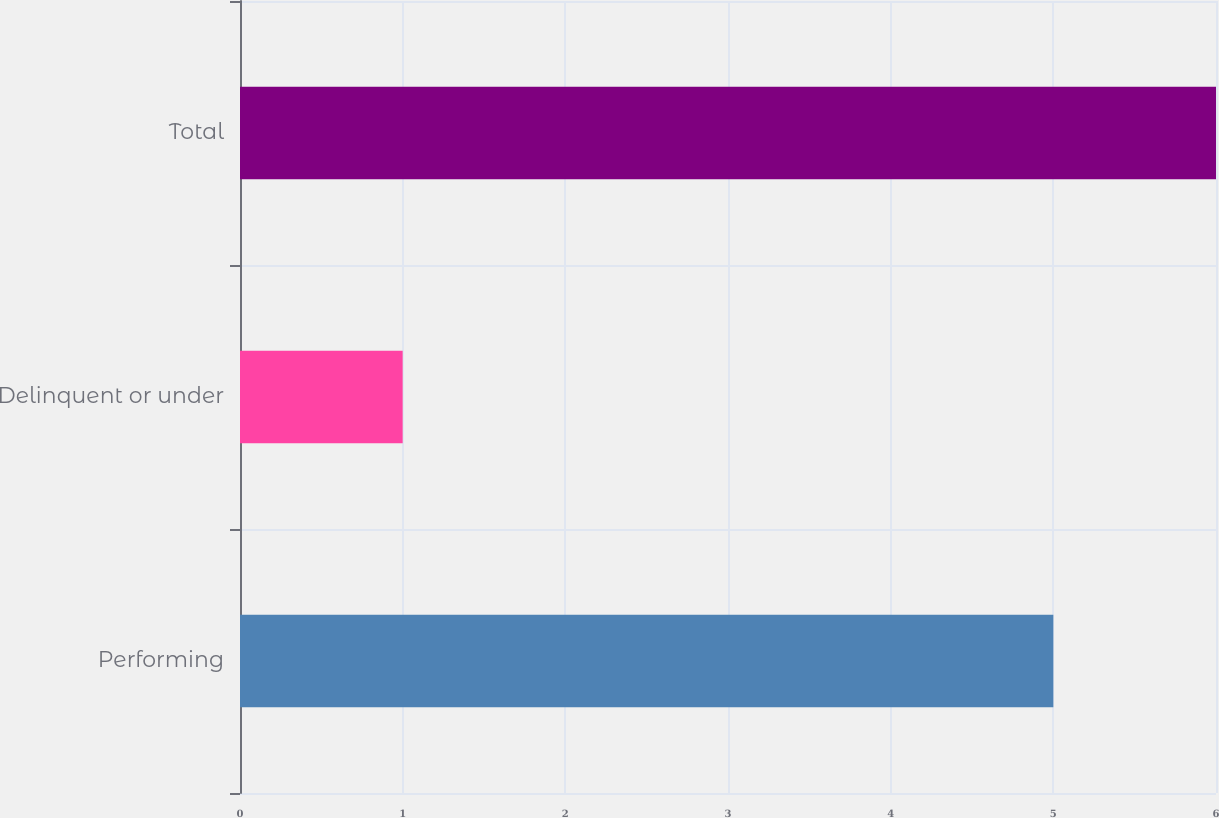Convert chart. <chart><loc_0><loc_0><loc_500><loc_500><bar_chart><fcel>Performing<fcel>Delinquent or under<fcel>Total<nl><fcel>5<fcel>1<fcel>6<nl></chart> 